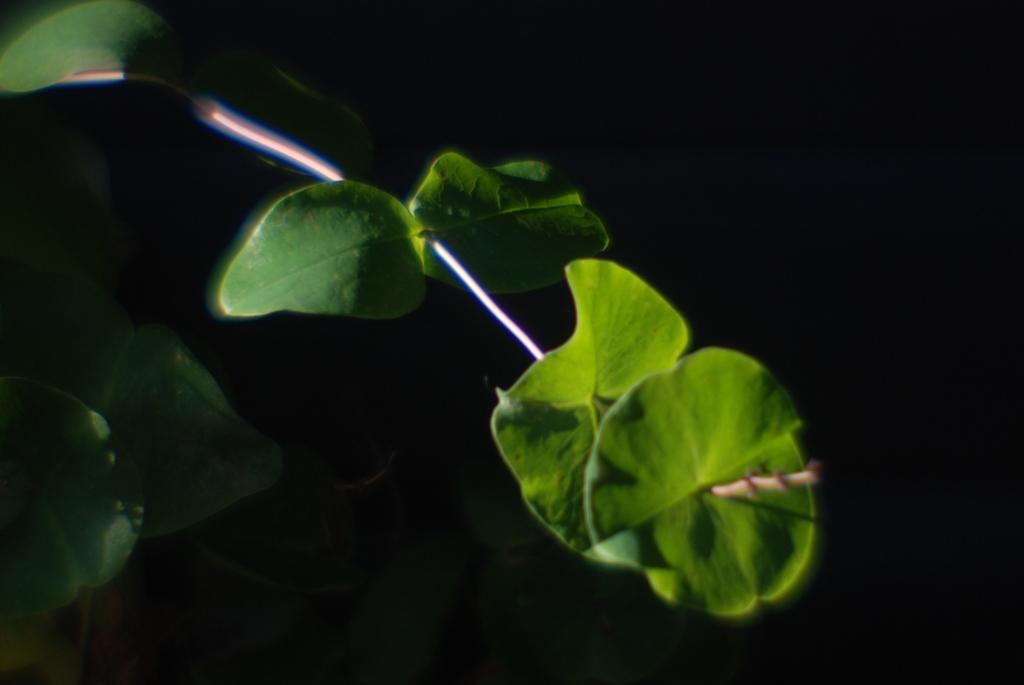What is present in the image? There is a plant in the image. What color is the plant? The plant is green in color. What can be seen in the background of the image? The background of the image is black. How many chickens are present in the image? There are no chickens present in the image; it only features a plant. What type of coil is used to support the plant in the image? There is no coil visible in the image; the plant is not shown being supported by any specific structure. 